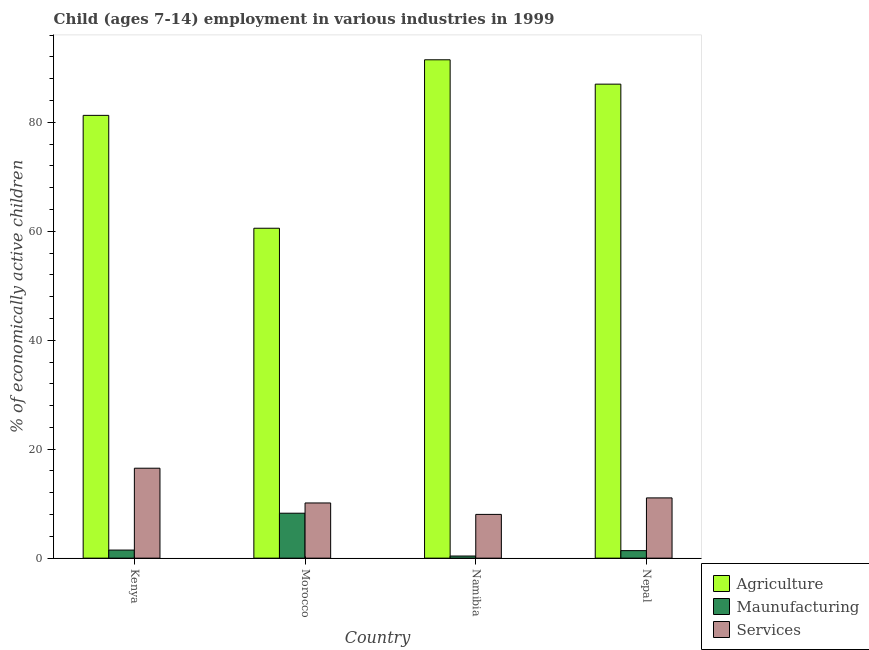Are the number of bars per tick equal to the number of legend labels?
Make the answer very short. Yes. What is the label of the 1st group of bars from the left?
Ensure brevity in your answer.  Kenya. What is the percentage of economically active children in manufacturing in Namibia?
Offer a very short reply. 0.39. Across all countries, what is the maximum percentage of economically active children in manufacturing?
Offer a very short reply. 8.25. Across all countries, what is the minimum percentage of economically active children in manufacturing?
Keep it short and to the point. 0.39. In which country was the percentage of economically active children in agriculture maximum?
Make the answer very short. Namibia. In which country was the percentage of economically active children in manufacturing minimum?
Offer a terse response. Namibia. What is the total percentage of economically active children in agriculture in the graph?
Give a very brief answer. 320.33. What is the difference between the percentage of economically active children in manufacturing in Morocco and that in Nepal?
Your answer should be compact. 6.87. What is the difference between the percentage of economically active children in manufacturing in Kenya and the percentage of economically active children in agriculture in Nepal?
Give a very brief answer. -85.53. What is the average percentage of economically active children in agriculture per country?
Provide a succinct answer. 80.08. What is the difference between the percentage of economically active children in services and percentage of economically active children in manufacturing in Namibia?
Give a very brief answer. 7.64. What is the ratio of the percentage of economically active children in services in Morocco to that in Namibia?
Provide a short and direct response. 1.26. What is the difference between the highest and the second highest percentage of economically active children in services?
Give a very brief answer. 5.45. What is the difference between the highest and the lowest percentage of economically active children in manufacturing?
Keep it short and to the point. 7.86. In how many countries, is the percentage of economically active children in manufacturing greater than the average percentage of economically active children in manufacturing taken over all countries?
Your response must be concise. 1. Is the sum of the percentage of economically active children in agriculture in Kenya and Morocco greater than the maximum percentage of economically active children in manufacturing across all countries?
Your response must be concise. Yes. What does the 3rd bar from the left in Kenya represents?
Give a very brief answer. Services. What does the 2nd bar from the right in Namibia represents?
Make the answer very short. Maunufacturing. How many countries are there in the graph?
Your answer should be compact. 4. Does the graph contain grids?
Your answer should be very brief. No. Where does the legend appear in the graph?
Make the answer very short. Bottom right. How many legend labels are there?
Offer a very short reply. 3. What is the title of the graph?
Provide a succinct answer. Child (ages 7-14) employment in various industries in 1999. Does "Oil" appear as one of the legend labels in the graph?
Your answer should be compact. No. What is the label or title of the X-axis?
Keep it short and to the point. Country. What is the label or title of the Y-axis?
Offer a terse response. % of economically active children. What is the % of economically active children of Agriculture in Kenya?
Offer a very short reply. 81.28. What is the % of economically active children of Maunufacturing in Kenya?
Keep it short and to the point. 1.48. What is the % of economically active children in Services in Kenya?
Your answer should be very brief. 16.51. What is the % of economically active children of Agriculture in Morocco?
Keep it short and to the point. 60.56. What is the % of economically active children in Maunufacturing in Morocco?
Offer a very short reply. 8.25. What is the % of economically active children in Services in Morocco?
Your answer should be very brief. 10.13. What is the % of economically active children of Agriculture in Namibia?
Give a very brief answer. 91.48. What is the % of economically active children of Maunufacturing in Namibia?
Provide a short and direct response. 0.39. What is the % of economically active children of Services in Namibia?
Offer a very short reply. 8.03. What is the % of economically active children of Agriculture in Nepal?
Your answer should be very brief. 87.01. What is the % of economically active children in Maunufacturing in Nepal?
Ensure brevity in your answer.  1.38. What is the % of economically active children of Services in Nepal?
Your response must be concise. 11.06. Across all countries, what is the maximum % of economically active children of Agriculture?
Your answer should be very brief. 91.48. Across all countries, what is the maximum % of economically active children of Maunufacturing?
Provide a succinct answer. 8.25. Across all countries, what is the maximum % of economically active children of Services?
Keep it short and to the point. 16.51. Across all countries, what is the minimum % of economically active children of Agriculture?
Offer a terse response. 60.56. Across all countries, what is the minimum % of economically active children of Maunufacturing?
Make the answer very short. 0.39. Across all countries, what is the minimum % of economically active children in Services?
Give a very brief answer. 8.03. What is the total % of economically active children in Agriculture in the graph?
Offer a very short reply. 320.33. What is the total % of economically active children of Maunufacturing in the graph?
Your response must be concise. 11.5. What is the total % of economically active children in Services in the graph?
Your answer should be compact. 45.73. What is the difference between the % of economically active children of Agriculture in Kenya and that in Morocco?
Keep it short and to the point. 20.72. What is the difference between the % of economically active children of Maunufacturing in Kenya and that in Morocco?
Give a very brief answer. -6.77. What is the difference between the % of economically active children of Services in Kenya and that in Morocco?
Provide a succinct answer. 6.38. What is the difference between the % of economically active children in Agriculture in Kenya and that in Namibia?
Ensure brevity in your answer.  -10.2. What is the difference between the % of economically active children in Maunufacturing in Kenya and that in Namibia?
Provide a short and direct response. 1.09. What is the difference between the % of economically active children in Services in Kenya and that in Namibia?
Your answer should be very brief. 8.48. What is the difference between the % of economically active children of Agriculture in Kenya and that in Nepal?
Your answer should be very brief. -5.73. What is the difference between the % of economically active children in Maunufacturing in Kenya and that in Nepal?
Ensure brevity in your answer.  0.1. What is the difference between the % of economically active children in Services in Kenya and that in Nepal?
Offer a terse response. 5.45. What is the difference between the % of economically active children in Agriculture in Morocco and that in Namibia?
Give a very brief answer. -30.92. What is the difference between the % of economically active children in Maunufacturing in Morocco and that in Namibia?
Ensure brevity in your answer.  7.86. What is the difference between the % of economically active children of Agriculture in Morocco and that in Nepal?
Ensure brevity in your answer.  -26.45. What is the difference between the % of economically active children of Maunufacturing in Morocco and that in Nepal?
Offer a terse response. 6.87. What is the difference between the % of economically active children in Services in Morocco and that in Nepal?
Provide a short and direct response. -0.93. What is the difference between the % of economically active children in Agriculture in Namibia and that in Nepal?
Offer a terse response. 4.47. What is the difference between the % of economically active children of Maunufacturing in Namibia and that in Nepal?
Provide a short and direct response. -0.99. What is the difference between the % of economically active children in Services in Namibia and that in Nepal?
Offer a terse response. -3.03. What is the difference between the % of economically active children in Agriculture in Kenya and the % of economically active children in Maunufacturing in Morocco?
Offer a very short reply. 73.03. What is the difference between the % of economically active children of Agriculture in Kenya and the % of economically active children of Services in Morocco?
Your response must be concise. 71.15. What is the difference between the % of economically active children in Maunufacturing in Kenya and the % of economically active children in Services in Morocco?
Make the answer very short. -8.65. What is the difference between the % of economically active children of Agriculture in Kenya and the % of economically active children of Maunufacturing in Namibia?
Offer a very short reply. 80.89. What is the difference between the % of economically active children of Agriculture in Kenya and the % of economically active children of Services in Namibia?
Offer a very short reply. 73.25. What is the difference between the % of economically active children in Maunufacturing in Kenya and the % of economically active children in Services in Namibia?
Your answer should be very brief. -6.55. What is the difference between the % of economically active children in Agriculture in Kenya and the % of economically active children in Maunufacturing in Nepal?
Give a very brief answer. 79.9. What is the difference between the % of economically active children in Agriculture in Kenya and the % of economically active children in Services in Nepal?
Keep it short and to the point. 70.22. What is the difference between the % of economically active children in Maunufacturing in Kenya and the % of economically active children in Services in Nepal?
Your answer should be very brief. -9.58. What is the difference between the % of economically active children in Agriculture in Morocco and the % of economically active children in Maunufacturing in Namibia?
Offer a terse response. 60.17. What is the difference between the % of economically active children in Agriculture in Morocco and the % of economically active children in Services in Namibia?
Give a very brief answer. 52.53. What is the difference between the % of economically active children in Maunufacturing in Morocco and the % of economically active children in Services in Namibia?
Your answer should be very brief. 0.22. What is the difference between the % of economically active children of Agriculture in Morocco and the % of economically active children of Maunufacturing in Nepal?
Your answer should be very brief. 59.18. What is the difference between the % of economically active children in Agriculture in Morocco and the % of economically active children in Services in Nepal?
Your answer should be compact. 49.5. What is the difference between the % of economically active children of Maunufacturing in Morocco and the % of economically active children of Services in Nepal?
Provide a short and direct response. -2.81. What is the difference between the % of economically active children of Agriculture in Namibia and the % of economically active children of Maunufacturing in Nepal?
Provide a succinct answer. 90.1. What is the difference between the % of economically active children of Agriculture in Namibia and the % of economically active children of Services in Nepal?
Offer a terse response. 80.42. What is the difference between the % of economically active children in Maunufacturing in Namibia and the % of economically active children in Services in Nepal?
Provide a short and direct response. -10.67. What is the average % of economically active children of Agriculture per country?
Your answer should be compact. 80.08. What is the average % of economically active children of Maunufacturing per country?
Provide a succinct answer. 2.88. What is the average % of economically active children of Services per country?
Provide a succinct answer. 11.43. What is the difference between the % of economically active children of Agriculture and % of economically active children of Maunufacturing in Kenya?
Your response must be concise. 79.8. What is the difference between the % of economically active children in Agriculture and % of economically active children in Services in Kenya?
Your response must be concise. 64.77. What is the difference between the % of economically active children of Maunufacturing and % of economically active children of Services in Kenya?
Ensure brevity in your answer.  -15.03. What is the difference between the % of economically active children of Agriculture and % of economically active children of Maunufacturing in Morocco?
Give a very brief answer. 52.31. What is the difference between the % of economically active children in Agriculture and % of economically active children in Services in Morocco?
Ensure brevity in your answer.  50.43. What is the difference between the % of economically active children of Maunufacturing and % of economically active children of Services in Morocco?
Your answer should be very brief. -1.88. What is the difference between the % of economically active children of Agriculture and % of economically active children of Maunufacturing in Namibia?
Offer a terse response. 91.09. What is the difference between the % of economically active children of Agriculture and % of economically active children of Services in Namibia?
Your answer should be very brief. 83.45. What is the difference between the % of economically active children in Maunufacturing and % of economically active children in Services in Namibia?
Provide a short and direct response. -7.64. What is the difference between the % of economically active children of Agriculture and % of economically active children of Maunufacturing in Nepal?
Ensure brevity in your answer.  85.63. What is the difference between the % of economically active children of Agriculture and % of economically active children of Services in Nepal?
Your answer should be very brief. 75.95. What is the difference between the % of economically active children in Maunufacturing and % of economically active children in Services in Nepal?
Offer a very short reply. -9.68. What is the ratio of the % of economically active children in Agriculture in Kenya to that in Morocco?
Offer a terse response. 1.34. What is the ratio of the % of economically active children of Maunufacturing in Kenya to that in Morocco?
Give a very brief answer. 0.18. What is the ratio of the % of economically active children of Services in Kenya to that in Morocco?
Your answer should be compact. 1.63. What is the ratio of the % of economically active children in Agriculture in Kenya to that in Namibia?
Provide a succinct answer. 0.89. What is the ratio of the % of economically active children of Maunufacturing in Kenya to that in Namibia?
Keep it short and to the point. 3.8. What is the ratio of the % of economically active children in Services in Kenya to that in Namibia?
Your answer should be very brief. 2.06. What is the ratio of the % of economically active children of Agriculture in Kenya to that in Nepal?
Your response must be concise. 0.93. What is the ratio of the % of economically active children in Maunufacturing in Kenya to that in Nepal?
Provide a succinct answer. 1.07. What is the ratio of the % of economically active children in Services in Kenya to that in Nepal?
Make the answer very short. 1.49. What is the ratio of the % of economically active children in Agriculture in Morocco to that in Namibia?
Make the answer very short. 0.66. What is the ratio of the % of economically active children in Maunufacturing in Morocco to that in Namibia?
Provide a succinct answer. 21.15. What is the ratio of the % of economically active children in Services in Morocco to that in Namibia?
Provide a short and direct response. 1.26. What is the ratio of the % of economically active children in Agriculture in Morocco to that in Nepal?
Offer a terse response. 0.7. What is the ratio of the % of economically active children in Maunufacturing in Morocco to that in Nepal?
Give a very brief answer. 5.98. What is the ratio of the % of economically active children of Services in Morocco to that in Nepal?
Offer a very short reply. 0.92. What is the ratio of the % of economically active children of Agriculture in Namibia to that in Nepal?
Keep it short and to the point. 1.05. What is the ratio of the % of economically active children of Maunufacturing in Namibia to that in Nepal?
Ensure brevity in your answer.  0.28. What is the ratio of the % of economically active children in Services in Namibia to that in Nepal?
Offer a very short reply. 0.73. What is the difference between the highest and the second highest % of economically active children of Agriculture?
Give a very brief answer. 4.47. What is the difference between the highest and the second highest % of economically active children in Maunufacturing?
Your response must be concise. 6.77. What is the difference between the highest and the second highest % of economically active children in Services?
Make the answer very short. 5.45. What is the difference between the highest and the lowest % of economically active children of Agriculture?
Your answer should be very brief. 30.92. What is the difference between the highest and the lowest % of economically active children in Maunufacturing?
Ensure brevity in your answer.  7.86. What is the difference between the highest and the lowest % of economically active children in Services?
Provide a succinct answer. 8.48. 